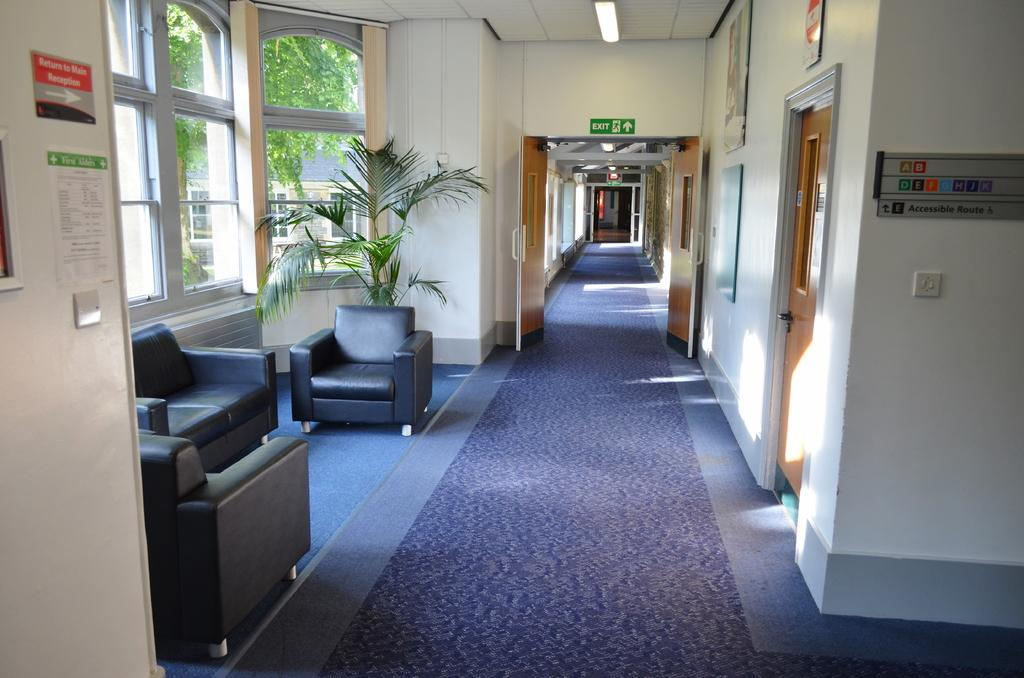What type of structure is present in the image? The image contains a building. What type of furniture can be found inside the building? There are sofas and chairs inside the building. Are there any decorative elements in the building? Yes, there are houseplants in the building. Can you describe the window in the building? There is a window in the building, and trees and another building are visible through it. What type of mask is the dad wearing on his knee in the image? There is no dad, mask, or knee present in the image. 